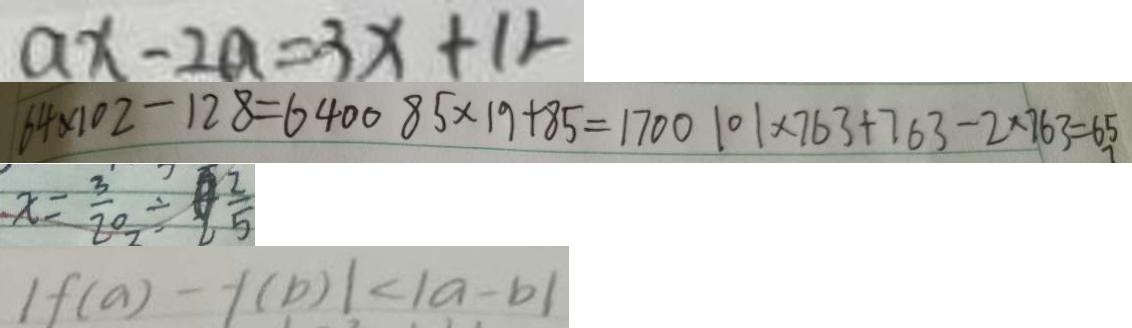<formula> <loc_0><loc_0><loc_500><loc_500>a x - 2 a = 3 x + 1 2 
 6 4 \times 1 0 2 - 1 2 8 = 6 4 0 0 8 5 \times 1 9 + 8 5 = 1 7 0 0 1 0 1 \times 7 6 3 + 7 6 3 - 2 \times 7 6 3 = 6 5 
 x = \frac { 3 } { 2 0 } \div \frac { 2 } { 5 } 
 1 f ( a ) - f ( b ) \vert < \vert a - b \vert</formula> 